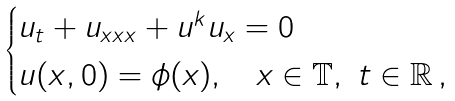Convert formula to latex. <formula><loc_0><loc_0><loc_500><loc_500>\begin{cases} u _ { t } + u _ { x x x } + u ^ { k } u _ { x } = 0 \\ u ( x , 0 ) = \phi ( x ) , \quad x \in \mathbb { T } , \ t \in \mathbb { R } \, , \end{cases}</formula> 